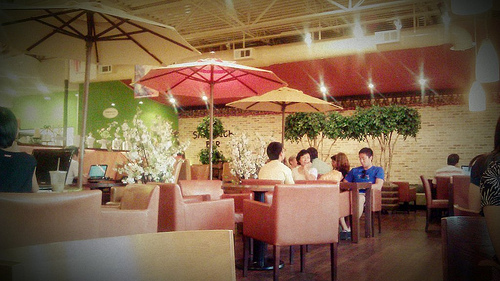How many people are wearing a blue shirt? 1 